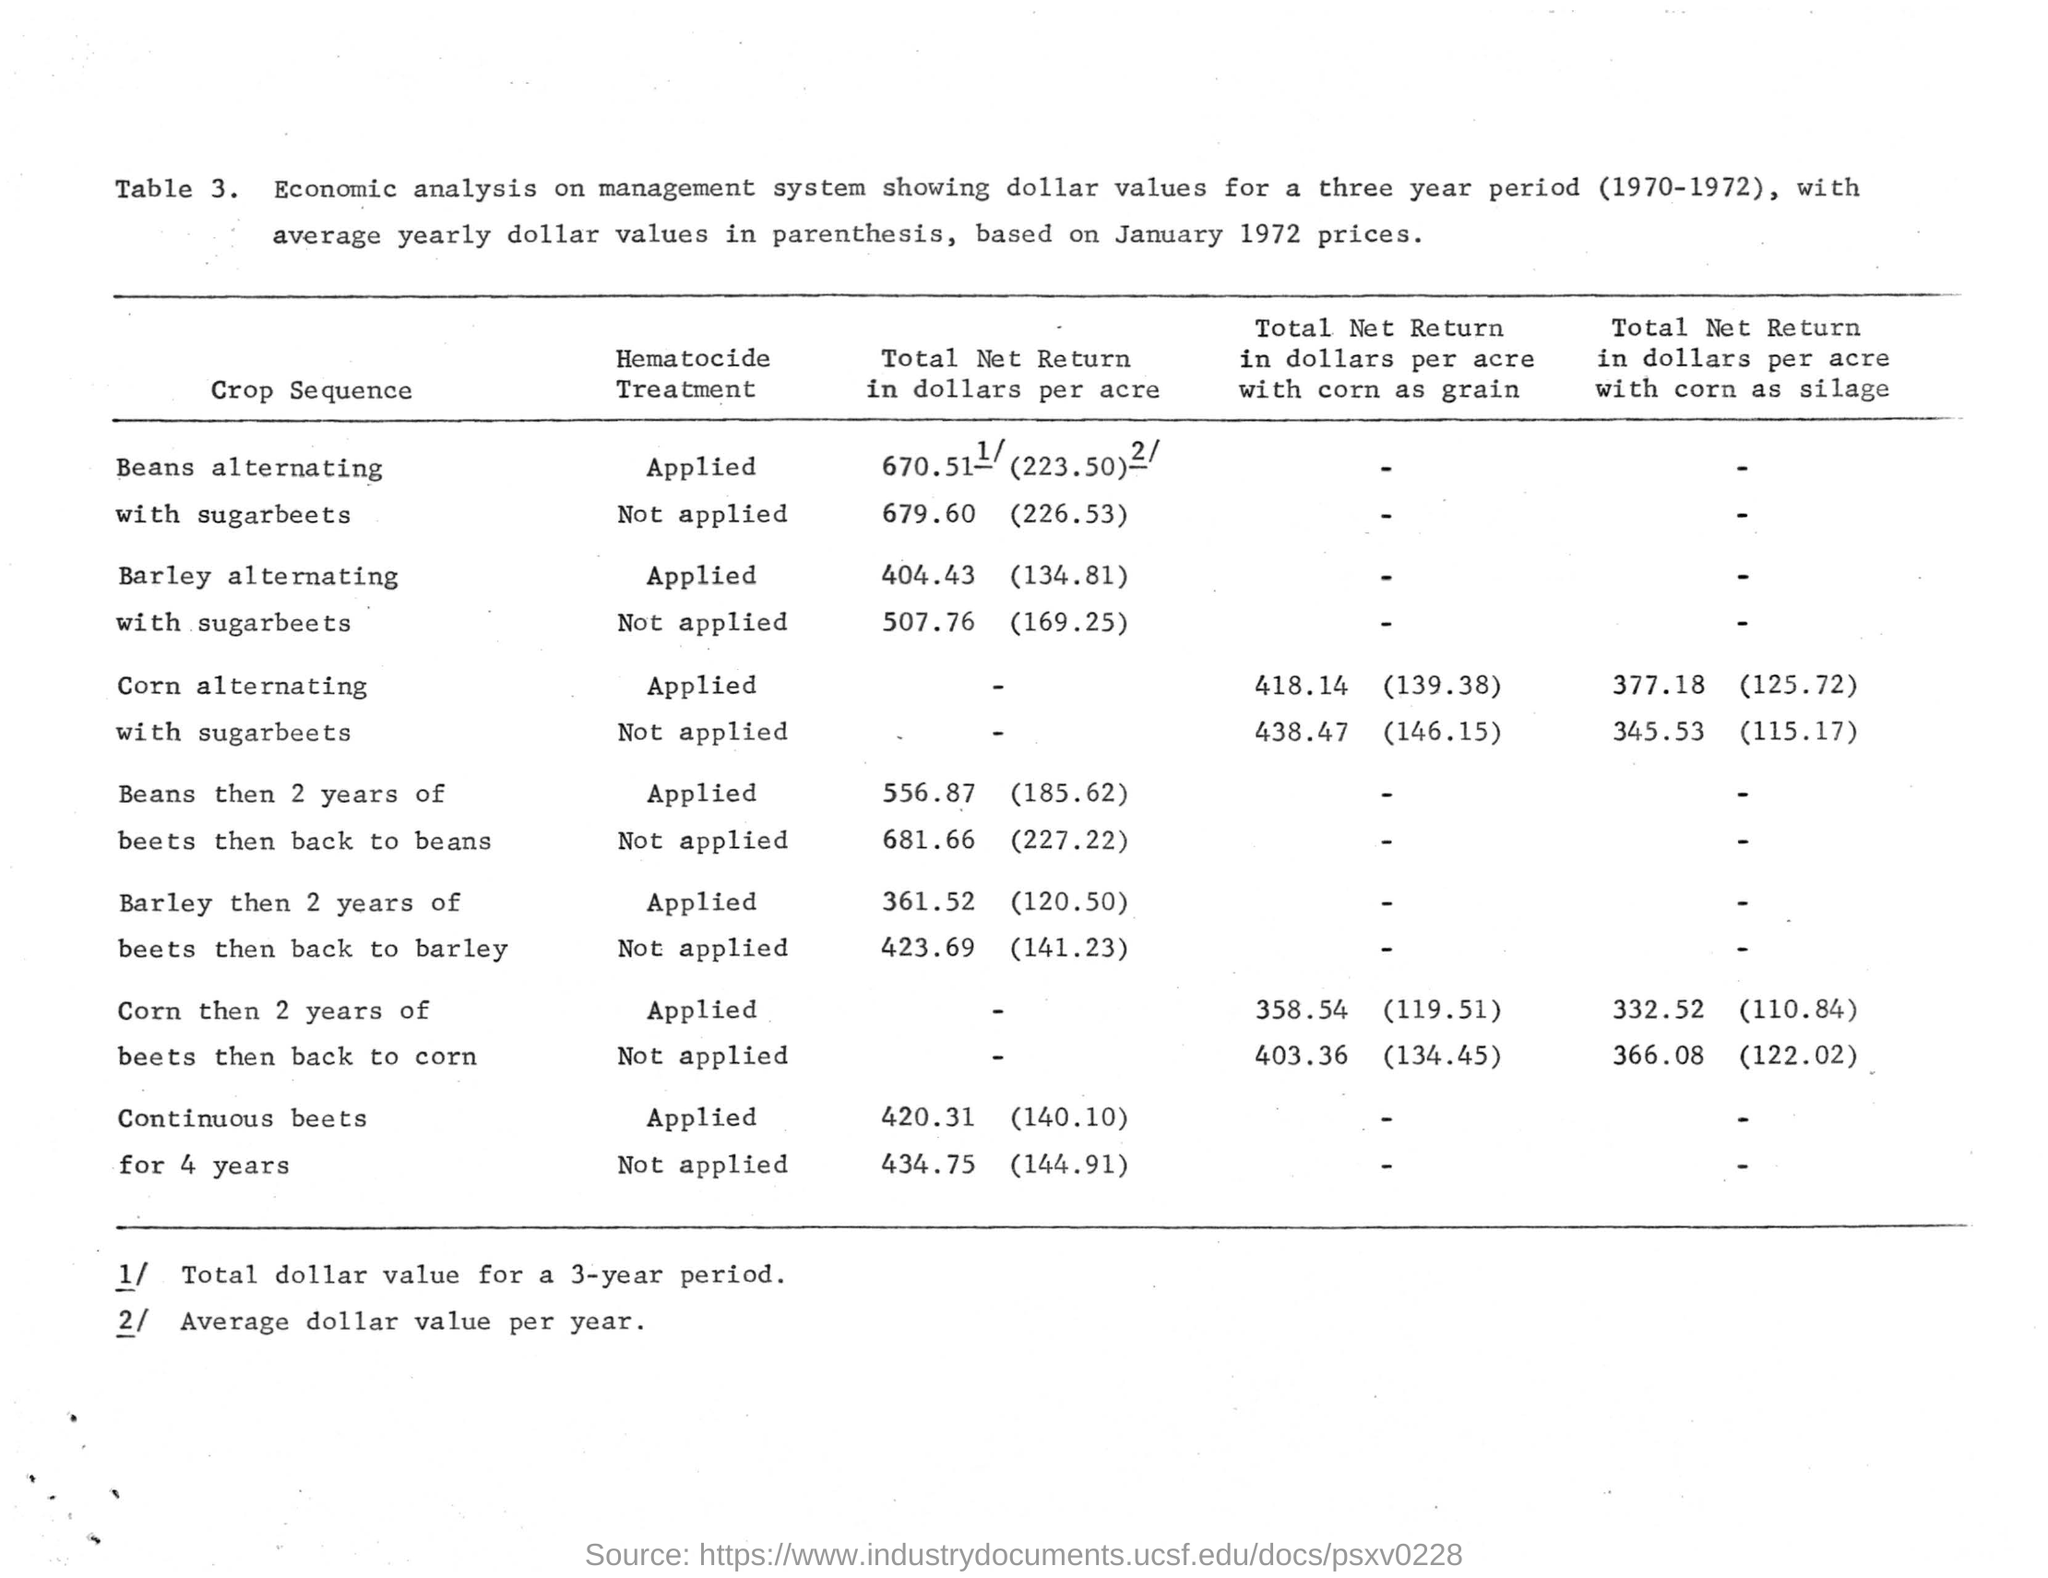Point out several critical features in this image. The average yearly dollar values shown in "Table 3" are based on January 1972 prices. The heading for the second column of the "Table" is "Hematocide Treatment. The first crop sequence mentioned in the table is beans alternating with corn, followed by beans alternating with wheat and then beans alternating with oats. What is the number of the table? It is 3. The last crop sequence mentioned in the table is for continuous beets for four years. 